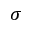Convert formula to latex. <formula><loc_0><loc_0><loc_500><loc_500>\sigma</formula> 